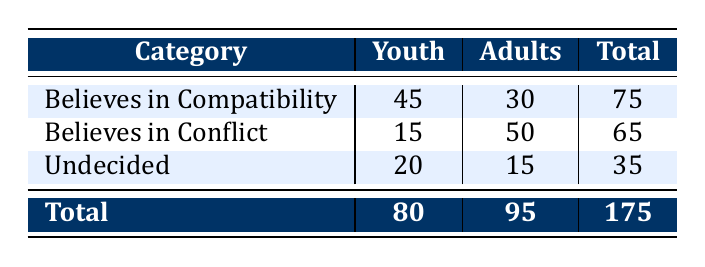What is the total number of youth who believe in compatibility? From the table, the number of youth who believe in compatibility is directly given as 45.
Answer: 45 What is the total number of adults who are undecided? The table indicates that the number of adults who are undecided is 15.
Answer: 15 How many people in total believe in conflict? We can find the total by adding the counts from both age groups: 15 (youth) + 50 (adults) = 65.
Answer: 65 Is it true that more adults believe in conflict than youth? The count for adults who believe in conflict is 50, while for youth, it is 15. Since 50 > 15, the statement is true.
Answer: Yes What is the difference in the number of youth and adults who believe in compatibility? Youth who believe in compatibility: 45; Adults who believe in compatibility: 30. The difference is 45 - 30 = 15.
Answer: 15 What percentage of the total respondents are youth who believe in compatibility? The total number of respondents is 175 (80 youth + 95 adults). The percentage of youth who believe in compatibility is (45 / 175) * 100 ≈ 25.71%.
Answer: 25.71% How many total respondents believe in compatibility or are undecided? We need to add the counts for both categories: 75 (believe in compatibility) + 35 (undecided) = 110.
Answer: 110 What is the average number of adults across all categories? To find the average, sum the adult counts (30 + 50 + 15 = 95) and divide by the number of categories (3). The average is 95 / 3 ≈ 31.67.
Answer: 31.67 What proportion of the total youth are undecided? The total youth is 80. The number of undecided youth is 20. Thus, the proportion is 20 / 80 = 0.25 or 25%.
Answer: 25% 